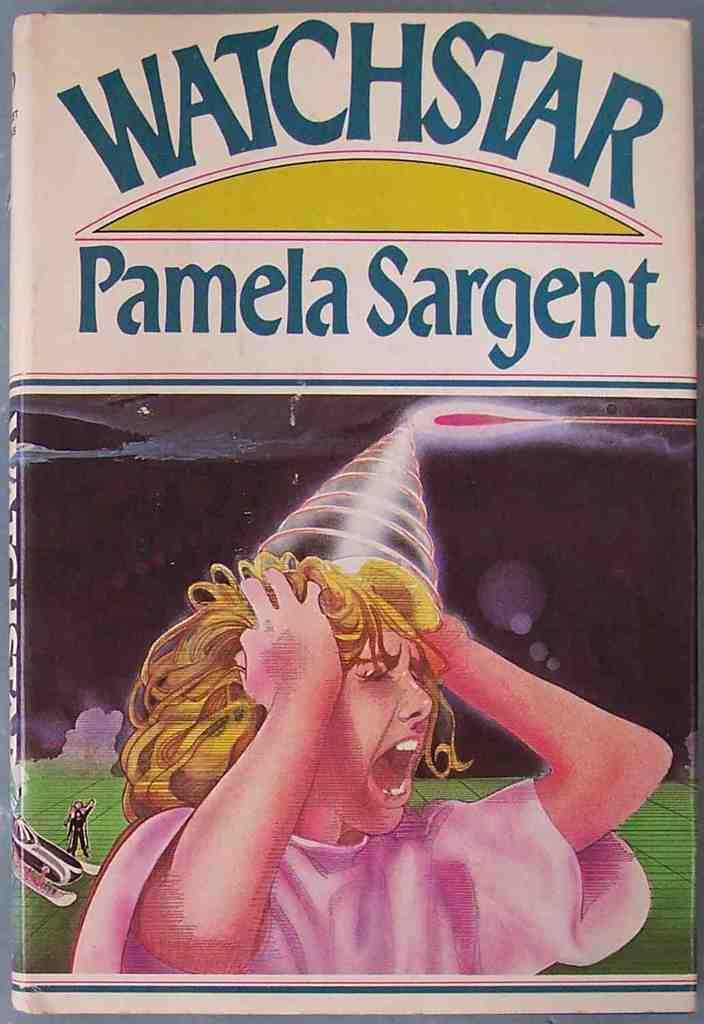What is the main subject of the image? The main subject of the image is a book cover. What can be seen on the book cover? The book cover has text on it and a depiction of a girl. Can you tell me how many ants are crawling on the girl's face on the book cover? There are no ants present on the girl's face on the book cover in the image. What type of frog can be seen sitting next to the girl on the book cover? There is no frog present on the book cover in the image. 